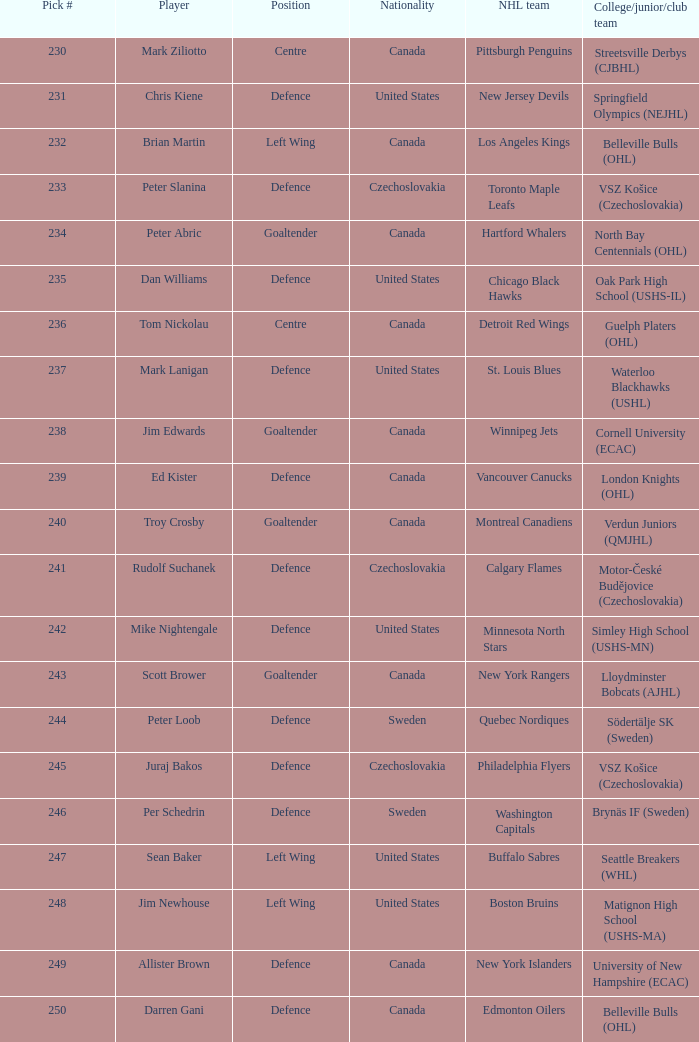The winnipeg jets are part of which organization? Cornell University (ECAC). 